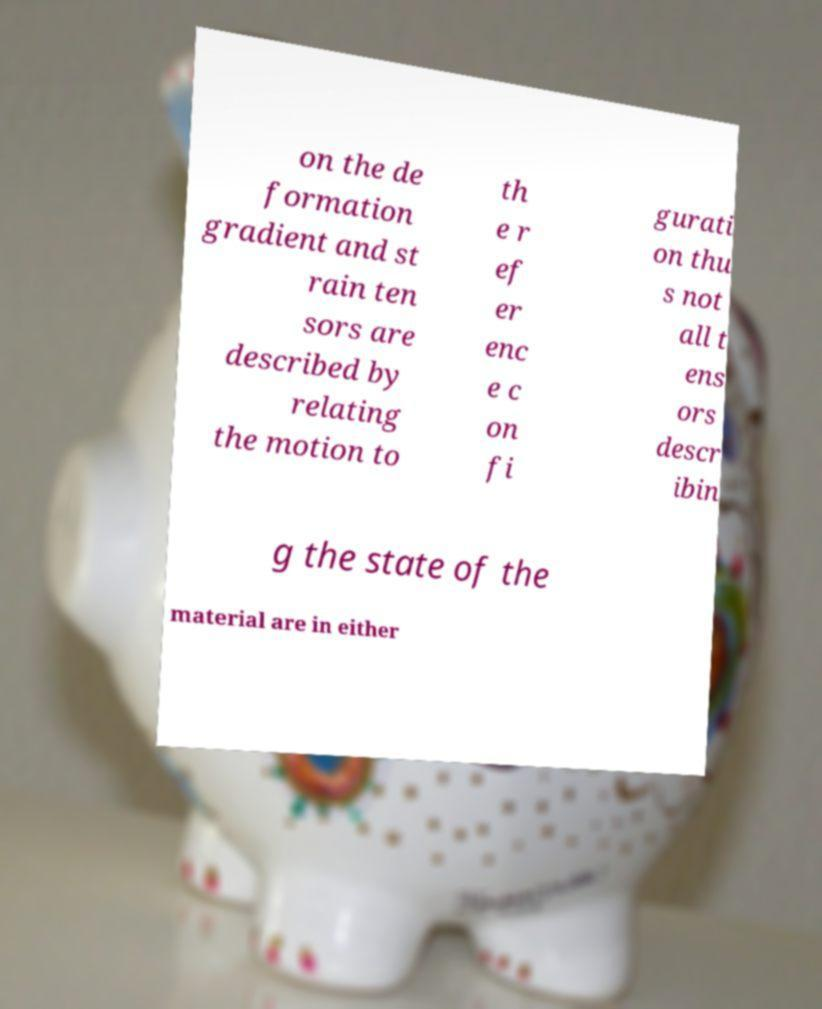I need the written content from this picture converted into text. Can you do that? on the de formation gradient and st rain ten sors are described by relating the motion to th e r ef er enc e c on fi gurati on thu s not all t ens ors descr ibin g the state of the material are in either 